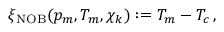Convert formula to latex. <formula><loc_0><loc_0><loc_500><loc_500>\xi _ { N O B } ( p _ { m } , T _ { m } , \chi _ { k } ) \colon = T _ { m } - T _ { c } \, ,</formula> 